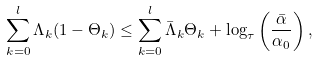<formula> <loc_0><loc_0><loc_500><loc_500>\sum _ { k = 0 } ^ { l } \Lambda _ { k } ( 1 - \Theta _ { k } ) \leq \sum _ { k = 0 } ^ { l } \bar { \Lambda } _ { k } \Theta _ { k } + \log _ { \tau } \left ( \frac { \bar { \alpha } } { \alpha _ { 0 } } \right ) ,</formula> 